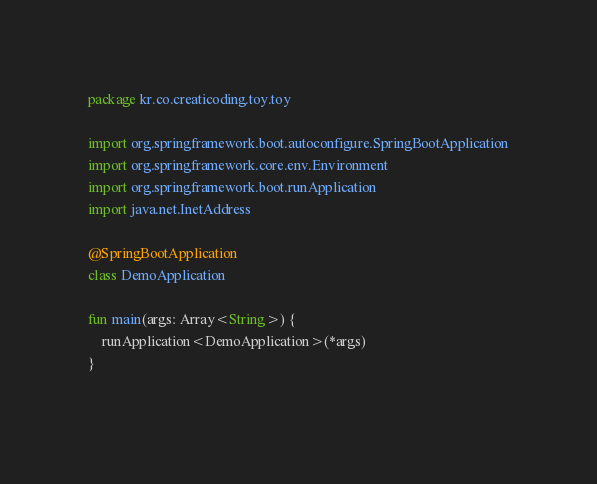<code> <loc_0><loc_0><loc_500><loc_500><_Kotlin_>package kr.co.creaticoding.toy.toy

import org.springframework.boot.autoconfigure.SpringBootApplication
import org.springframework.core.env.Environment
import org.springframework.boot.runApplication
import java.net.InetAddress

@SpringBootApplication
class DemoApplication

fun main(args: Array<String>) {
	runApplication<DemoApplication>(*args)
}
 </code> 